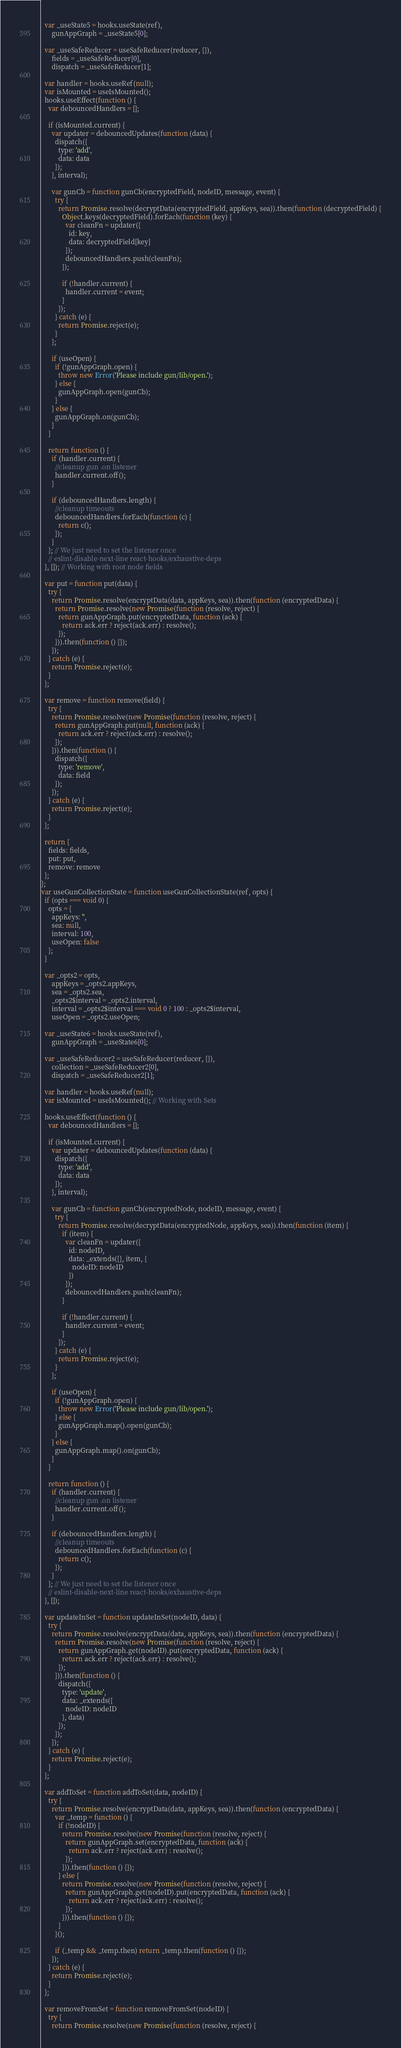Convert code to text. <code><loc_0><loc_0><loc_500><loc_500><_JavaScript_>  var _useState5 = hooks.useState(ref),
      gunAppGraph = _useState5[0];

  var _useSafeReducer = useSafeReducer(reducer, {}),
      fields = _useSafeReducer[0],
      dispatch = _useSafeReducer[1];

  var handler = hooks.useRef(null);
  var isMounted = useIsMounted();
  hooks.useEffect(function () {
    var debouncedHandlers = [];

    if (isMounted.current) {
      var updater = debouncedUpdates(function (data) {
        dispatch({
          type: 'add',
          data: data
        });
      }, interval);

      var gunCb = function gunCb(encryptedField, nodeID, message, event) {
        try {
          return Promise.resolve(decryptData(encryptedField, appKeys, sea)).then(function (decryptedField) {
            Object.keys(decryptedField).forEach(function (key) {
              var cleanFn = updater({
                id: key,
                data: decryptedField[key]
              });
              debouncedHandlers.push(cleanFn);
            });

            if (!handler.current) {
              handler.current = event;
            }
          });
        } catch (e) {
          return Promise.reject(e);
        }
      };

      if (useOpen) {
        if (!gunAppGraph.open) {
          throw new Error('Please include gun/lib/open.');
        } else {
          gunAppGraph.open(gunCb);
        }
      } else {
        gunAppGraph.on(gunCb);
      }
    }

    return function () {
      if (handler.current) {
        //cleanup gun .on listener
        handler.current.off();
      }

      if (debouncedHandlers.length) {
        //cleanup timeouts
        debouncedHandlers.forEach(function (c) {
          return c();
        });
      }
    }; // We just need to set the listener once
    // eslint-disable-next-line react-hooks/exhaustive-deps
  }, []); // Working with root node fields

  var put = function put(data) {
    try {
      return Promise.resolve(encryptData(data, appKeys, sea)).then(function (encryptedData) {
        return Promise.resolve(new Promise(function (resolve, reject) {
          return gunAppGraph.put(encryptedData, function (ack) {
            return ack.err ? reject(ack.err) : resolve();
          });
        })).then(function () {});
      });
    } catch (e) {
      return Promise.reject(e);
    }
  };

  var remove = function remove(field) {
    try {
      return Promise.resolve(new Promise(function (resolve, reject) {
        return gunAppGraph.put(null, function (ack) {
          return ack.err ? reject(ack.err) : resolve();
        });
      })).then(function () {
        dispatch({
          type: 'remove',
          data: field
        });
      });
    } catch (e) {
      return Promise.reject(e);
    }
  };

  return {
    fields: fields,
    put: put,
    remove: remove
  };
};
var useGunCollectionState = function useGunCollectionState(ref, opts) {
  if (opts === void 0) {
    opts = {
      appKeys: '',
      sea: null,
      interval: 100,
      useOpen: false
    };
  }

  var _opts2 = opts,
      appKeys = _opts2.appKeys,
      sea = _opts2.sea,
      _opts2$interval = _opts2.interval,
      interval = _opts2$interval === void 0 ? 100 : _opts2$interval,
      useOpen = _opts2.useOpen;

  var _useState6 = hooks.useState(ref),
      gunAppGraph = _useState6[0];

  var _useSafeReducer2 = useSafeReducer(reducer, {}),
      collection = _useSafeReducer2[0],
      dispatch = _useSafeReducer2[1];

  var handler = hooks.useRef(null);
  var isMounted = useIsMounted(); // Working with Sets

  hooks.useEffect(function () {
    var debouncedHandlers = [];

    if (isMounted.current) {
      var updater = debouncedUpdates(function (data) {
        dispatch({
          type: 'add',
          data: data
        });
      }, interval);

      var gunCb = function gunCb(encryptedNode, nodeID, message, event) {
        try {
          return Promise.resolve(decryptData(encryptedNode, appKeys, sea)).then(function (item) {
            if (item) {
              var cleanFn = updater({
                id: nodeID,
                data: _extends({}, item, {
                  nodeID: nodeID
                })
              });
              debouncedHandlers.push(cleanFn);
            }

            if (!handler.current) {
              handler.current = event;
            }
          });
        } catch (e) {
          return Promise.reject(e);
        }
      };

      if (useOpen) {
        if (!gunAppGraph.open) {
          throw new Error('Please include gun/lib/open.');
        } else {
          gunAppGraph.map().open(gunCb);
        }
      } else {
        gunAppGraph.map().on(gunCb);
      }
    }

    return function () {
      if (handler.current) {
        //cleanup gun .on listener
        handler.current.off();
      }

      if (debouncedHandlers.length) {
        //cleanup timeouts
        debouncedHandlers.forEach(function (c) {
          return c();
        });
      }
    }; // We just need to set the listener once
    // eslint-disable-next-line react-hooks/exhaustive-deps
  }, []);

  var updateInSet = function updateInSet(nodeID, data) {
    try {
      return Promise.resolve(encryptData(data, appKeys, sea)).then(function (encryptedData) {
        return Promise.resolve(new Promise(function (resolve, reject) {
          return gunAppGraph.get(nodeID).put(encryptedData, function (ack) {
            return ack.err ? reject(ack.err) : resolve();
          });
        })).then(function () {
          dispatch({
            type: 'update',
            data: _extends({
              nodeID: nodeID
            }, data)
          });
        });
      });
    } catch (e) {
      return Promise.reject(e);
    }
  };

  var addToSet = function addToSet(data, nodeID) {
    try {
      return Promise.resolve(encryptData(data, appKeys, sea)).then(function (encryptedData) {
        var _temp = function () {
          if (!nodeID) {
            return Promise.resolve(new Promise(function (resolve, reject) {
              return gunAppGraph.set(encryptedData, function (ack) {
                return ack.err ? reject(ack.err) : resolve();
              });
            })).then(function () {});
          } else {
            return Promise.resolve(new Promise(function (resolve, reject) {
              return gunAppGraph.get(nodeID).put(encryptedData, function (ack) {
                return ack.err ? reject(ack.err) : resolve();
              });
            })).then(function () {});
          }
        }();

        if (_temp && _temp.then) return _temp.then(function () {});
      });
    } catch (e) {
      return Promise.reject(e);
    }
  };

  var removeFromSet = function removeFromSet(nodeID) {
    try {
      return Promise.resolve(new Promise(function (resolve, reject) {</code> 